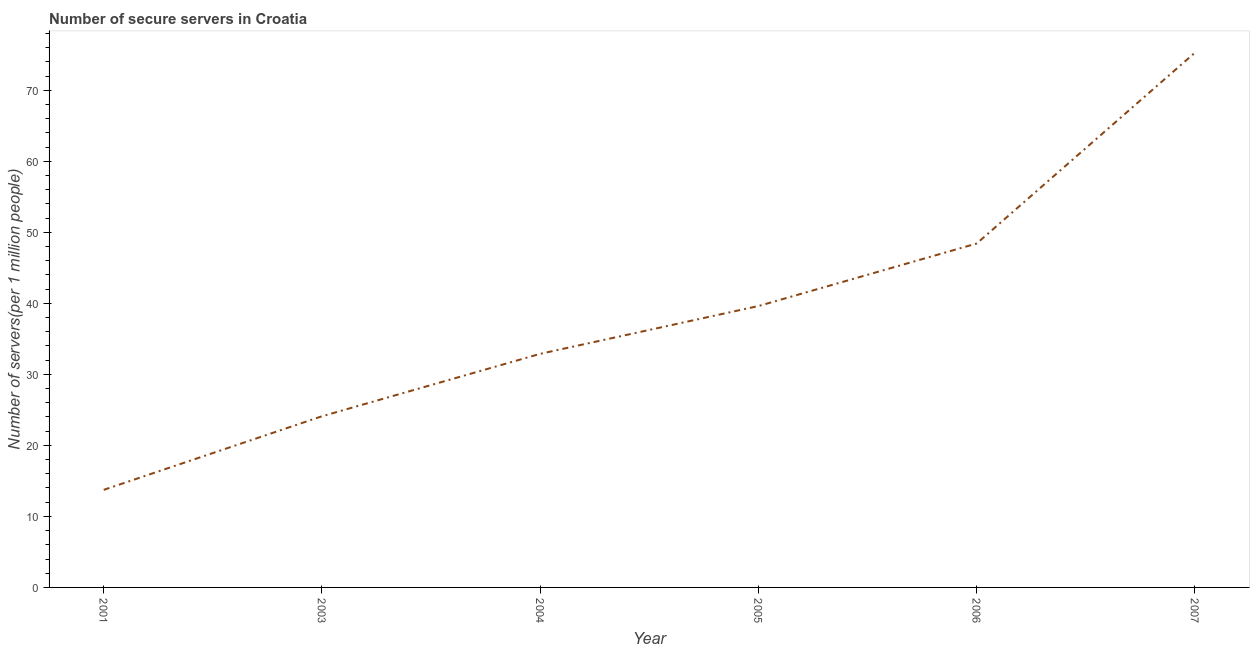What is the number of secure internet servers in 2007?
Your response must be concise. 75.29. Across all years, what is the maximum number of secure internet servers?
Your answer should be compact. 75.29. Across all years, what is the minimum number of secure internet servers?
Provide a short and direct response. 13.74. In which year was the number of secure internet servers maximum?
Make the answer very short. 2007. What is the sum of the number of secure internet servers?
Make the answer very short. 234.07. What is the difference between the number of secure internet servers in 2004 and 2006?
Your response must be concise. -15.53. What is the average number of secure internet servers per year?
Your response must be concise. 39.01. What is the median number of secure internet servers?
Ensure brevity in your answer.  36.26. In how many years, is the number of secure internet servers greater than 54 ?
Provide a succinct answer. 1. Do a majority of the years between 2006 and 2003 (inclusive) have number of secure internet servers greater than 66 ?
Make the answer very short. Yes. What is the ratio of the number of secure internet servers in 2004 to that in 2006?
Ensure brevity in your answer.  0.68. Is the difference between the number of secure internet servers in 2003 and 2004 greater than the difference between any two years?
Your answer should be very brief. No. What is the difference between the highest and the second highest number of secure internet servers?
Make the answer very short. 26.87. What is the difference between the highest and the lowest number of secure internet servers?
Give a very brief answer. 61.55. In how many years, is the number of secure internet servers greater than the average number of secure internet servers taken over all years?
Keep it short and to the point. 3. What is the difference between two consecutive major ticks on the Y-axis?
Ensure brevity in your answer.  10. Are the values on the major ticks of Y-axis written in scientific E-notation?
Offer a very short reply. No. Does the graph contain any zero values?
Your response must be concise. No. Does the graph contain grids?
Offer a very short reply. No. What is the title of the graph?
Provide a succinct answer. Number of secure servers in Croatia. What is the label or title of the X-axis?
Offer a terse response. Year. What is the label or title of the Y-axis?
Offer a very short reply. Number of servers(per 1 million people). What is the Number of servers(per 1 million people) of 2001?
Give a very brief answer. 13.74. What is the Number of servers(per 1 million people) of 2003?
Provide a succinct answer. 24.1. What is the Number of servers(per 1 million people) in 2004?
Your response must be concise. 32.89. What is the Number of servers(per 1 million people) in 2005?
Your answer should be very brief. 39.62. What is the Number of servers(per 1 million people) of 2006?
Your response must be concise. 48.42. What is the Number of servers(per 1 million people) of 2007?
Your answer should be very brief. 75.29. What is the difference between the Number of servers(per 1 million people) in 2001 and 2003?
Your response must be concise. -10.36. What is the difference between the Number of servers(per 1 million people) in 2001 and 2004?
Your answer should be compact. -19.15. What is the difference between the Number of servers(per 1 million people) in 2001 and 2005?
Your answer should be compact. -25.88. What is the difference between the Number of servers(per 1 million people) in 2001 and 2006?
Ensure brevity in your answer.  -34.68. What is the difference between the Number of servers(per 1 million people) in 2001 and 2007?
Offer a very short reply. -61.55. What is the difference between the Number of servers(per 1 million people) in 2003 and 2004?
Ensure brevity in your answer.  -8.79. What is the difference between the Number of servers(per 1 million people) in 2003 and 2005?
Provide a succinct answer. -15.52. What is the difference between the Number of servers(per 1 million people) in 2003 and 2006?
Provide a succinct answer. -24.32. What is the difference between the Number of servers(per 1 million people) in 2003 and 2007?
Your response must be concise. -51.19. What is the difference between the Number of servers(per 1 million people) in 2004 and 2005?
Provide a short and direct response. -6.73. What is the difference between the Number of servers(per 1 million people) in 2004 and 2006?
Give a very brief answer. -15.53. What is the difference between the Number of servers(per 1 million people) in 2004 and 2007?
Give a very brief answer. -42.4. What is the difference between the Number of servers(per 1 million people) in 2005 and 2006?
Offer a very short reply. -8.8. What is the difference between the Number of servers(per 1 million people) in 2005 and 2007?
Offer a terse response. -35.67. What is the difference between the Number of servers(per 1 million people) in 2006 and 2007?
Keep it short and to the point. -26.87. What is the ratio of the Number of servers(per 1 million people) in 2001 to that in 2003?
Provide a succinct answer. 0.57. What is the ratio of the Number of servers(per 1 million people) in 2001 to that in 2004?
Make the answer very short. 0.42. What is the ratio of the Number of servers(per 1 million people) in 2001 to that in 2005?
Provide a short and direct response. 0.35. What is the ratio of the Number of servers(per 1 million people) in 2001 to that in 2006?
Your answer should be very brief. 0.28. What is the ratio of the Number of servers(per 1 million people) in 2001 to that in 2007?
Give a very brief answer. 0.18. What is the ratio of the Number of servers(per 1 million people) in 2003 to that in 2004?
Keep it short and to the point. 0.73. What is the ratio of the Number of servers(per 1 million people) in 2003 to that in 2005?
Keep it short and to the point. 0.61. What is the ratio of the Number of servers(per 1 million people) in 2003 to that in 2006?
Make the answer very short. 0.5. What is the ratio of the Number of servers(per 1 million people) in 2003 to that in 2007?
Provide a succinct answer. 0.32. What is the ratio of the Number of servers(per 1 million people) in 2004 to that in 2005?
Offer a very short reply. 0.83. What is the ratio of the Number of servers(per 1 million people) in 2004 to that in 2006?
Ensure brevity in your answer.  0.68. What is the ratio of the Number of servers(per 1 million people) in 2004 to that in 2007?
Provide a succinct answer. 0.44. What is the ratio of the Number of servers(per 1 million people) in 2005 to that in 2006?
Give a very brief answer. 0.82. What is the ratio of the Number of servers(per 1 million people) in 2005 to that in 2007?
Offer a terse response. 0.53. What is the ratio of the Number of servers(per 1 million people) in 2006 to that in 2007?
Ensure brevity in your answer.  0.64. 